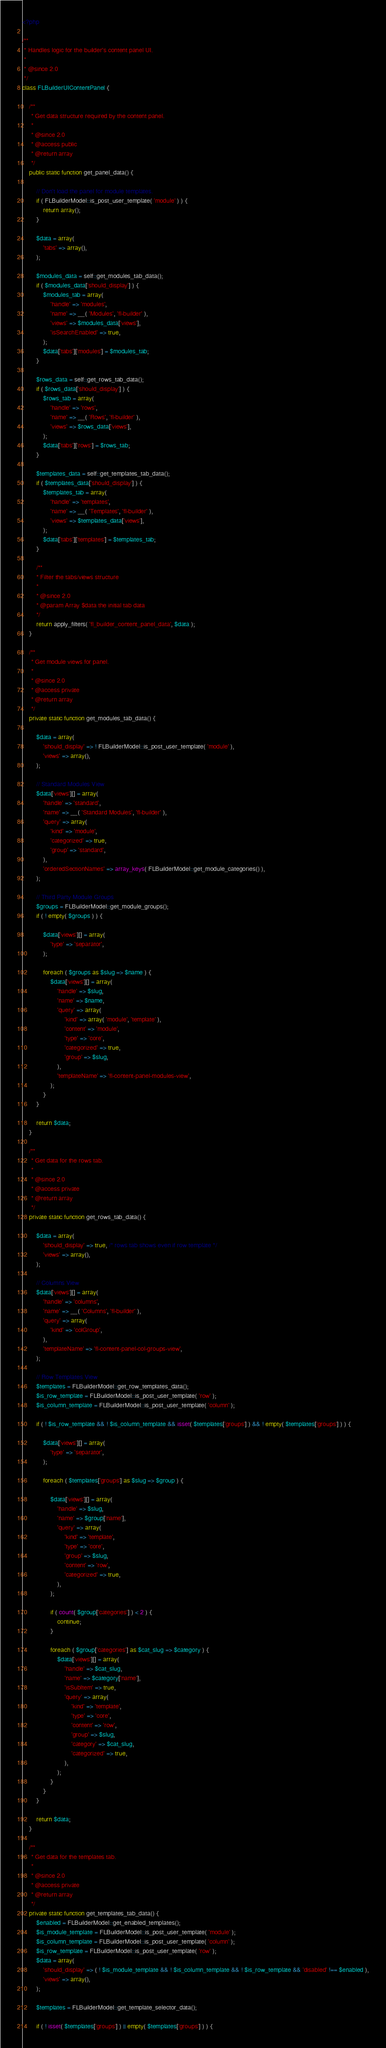<code> <loc_0><loc_0><loc_500><loc_500><_PHP_><?php

/**
 * Handles logic for the builder's content panel UI.
 *
 * @since 2.0
 */
class FLBuilderUIContentPanel {

	/**
	 * Get data structure required by the content panel.
	 *
	 * @since 2.0
	 * @access public
	 * @return array
	 */
	public static function get_panel_data() {

		// Don't load the panel for module templates.
		if ( FLBuilderModel::is_post_user_template( 'module' ) ) {
			return array();
		}

		$data = array(
			'tabs' => array(),
		);

		$modules_data = self::get_modules_tab_data();
		if ( $modules_data['should_display'] ) {
			$modules_tab = array(
				'handle' => 'modules',
				'name' => __( 'Modules', 'fl-builder' ),
				'views' => $modules_data['views'],
				'isSearchEnabled' => true,
			);
			$data['tabs']['modules'] = $modules_tab;
		}

		$rows_data = self::get_rows_tab_data();
		if ( $rows_data['should_display'] ) {
			$rows_tab = array(
				'handle' => 'rows',
				'name' => __( 'Rows', 'fl-builder' ),
				'views' => $rows_data['views'],
			);
			$data['tabs']['rows'] = $rows_tab;
		}

		$templates_data = self::get_templates_tab_data();
		if ( $templates_data['should_display'] ) {
			$templates_tab = array(
				'handle' => 'templates',
				'name' => __( 'Templates', 'fl-builder' ),
				'views' => $templates_data['views'],
			);
			$data['tabs']['templates'] = $templates_tab;
		}

		/**
		* Filter the tabs/views structure
		*
		* @since 2.0
		* @param Array $data the initial tab data
		*/
		return apply_filters( 'fl_builder_content_panel_data', $data );
	}

	/**
	 * Get module views for panel.
	 *
	 * @since 2.0
	 * @access private
	 * @return array
	 */
	private static function get_modules_tab_data() {

		$data = array(
			'should_display' => ! FLBuilderModel::is_post_user_template( 'module' ),
			'views' => array(),
		);

		// Standard Modules View
		$data['views'][] = array(
			'handle' => 'standard',
			'name' => __( 'Standard Modules', 'fl-builder' ),
			'query' => array(
				'kind' => 'module',
				'categorized' => true,
				'group' => 'standard',
			),
			'orderedSectionNames' => array_keys( FLBuilderModel::get_module_categories() ),
		);

		// Third Party Module Groups
		$groups = FLBuilderModel::get_module_groups();
		if ( ! empty( $groups ) ) {

			$data['views'][] = array(
				'type' => 'separator',
			);

			foreach ( $groups as $slug => $name ) {
				$data['views'][] = array(
					'handle' => $slug,
					'name' => $name,
					'query' => array(
						'kind' => array( 'module', 'template' ),
						'content' => 'module',
						'type' => 'core',
						'categorized' => true,
						'group' => $slug,
					),
					'templateName' => 'fl-content-panel-modules-view',
				);
			}
		}

		return $data;
	}

	/**
	 * Get data for the rows tab.
	 *
	 * @since 2.0
	 * @access private
	 * @return array
	 */
	private static function get_rows_tab_data() {

		$data = array(
			'should_display' => true, /* rows tab shows even if row template */
			'views' => array(),
		);

		// Columns View
		$data['views'][] = array(
			'handle' => 'columns',
			'name' => __( 'Columns', 'fl-builder' ),
			'query' => array(
				'kind' => 'colGroup',
			),
			'templateName' => 'fl-content-panel-col-groups-view',
		);

		// Row Templates View
		$templates = FLBuilderModel::get_row_templates_data();
		$is_row_template = FLBuilderModel::is_post_user_template( 'row' );
		$is_column_template = FLBuilderModel::is_post_user_template( 'column' );

		if ( ! $is_row_template && ! $is_column_template && isset( $templates['groups'] ) && ! empty( $templates['groups'] ) ) {

			$data['views'][] = array(
				'type' => 'separator',
			);

			foreach ( $templates['groups'] as $slug => $group ) {

				$data['views'][] = array(
					'handle' => $slug,
					'name' => $group['name'],
					'query' => array(
						'kind' => 'template',
						'type' => 'core',
						'group' => $slug,
						'content' => 'row',
						'categorized' => true,
					),
				);

				if ( count( $group['categories'] ) < 2 ) {
					continue;
				}

				foreach ( $group['categories'] as $cat_slug => $category ) {
					$data['views'][] = array(
						'handle' => $cat_slug,
						'name' => $category['name'],
						'isSubItem' => true,
						'query' => array(
							'kind' => 'template',
							'type' => 'core',
							'content' => 'row',
							'group' => $slug,
							'category' => $cat_slug,
							'categorized' => true,
						),
					);
				}
			}
		}

		return $data;
	}

	/**
	 * Get data for the templates tab.
	 *
	 * @since 2.0
	 * @access private
	 * @return array
	 */
	private static function get_templates_tab_data() {
		$enabled = FLBuilderModel::get_enabled_templates();
		$is_module_template = FLBuilderModel::is_post_user_template( 'module' );
		$is_column_template = FLBuilderModel::is_post_user_template( 'column' );
		$is_row_template = FLBuilderModel::is_post_user_template( 'row' );
		$data = array(
			'should_display' => ( ! $is_module_template && ! $is_column_template && ! $is_row_template && 'disabled' !== $enabled ),
			'views' => array(),
		);

		$templates = FLBuilderModel::get_template_selector_data();

		if ( ! isset( $templates['groups'] ) || empty( $templates['groups'] ) ) {
</code> 